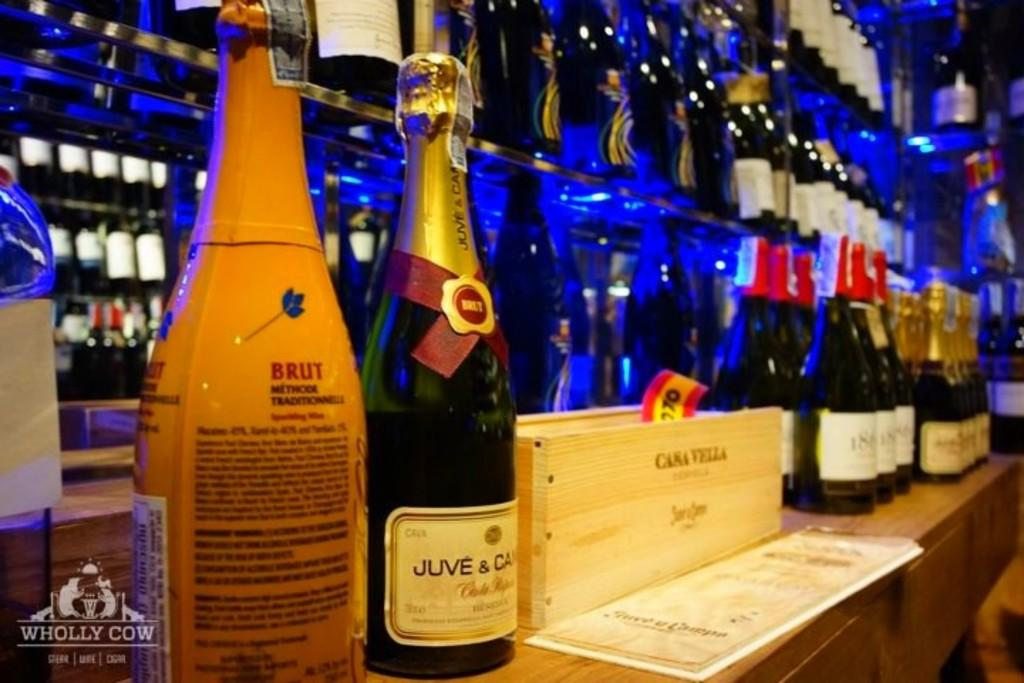<image>
Render a clear and concise summary of the photo. The wine on the counter is Juve & Ca. 